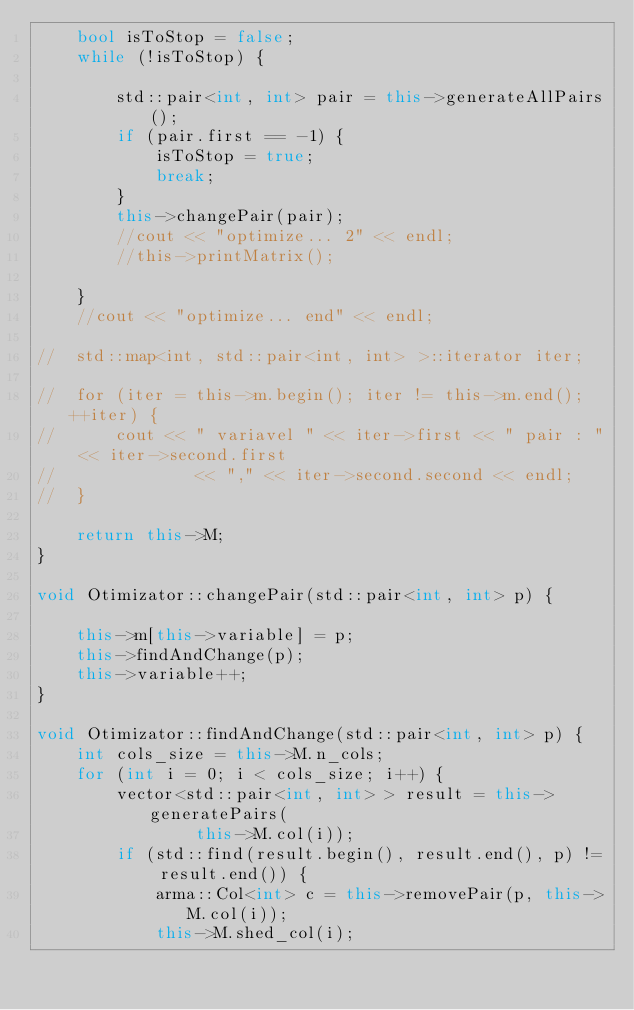Convert code to text. <code><loc_0><loc_0><loc_500><loc_500><_C++_>	bool isToStop = false;
	while (!isToStop) {

		std::pair<int, int> pair = this->generateAllPairs();
		if (pair.first == -1) {
			isToStop = true;
			break;
		}
		this->changePair(pair);
		//cout << "optimize... 2" << endl;
		//this->printMatrix();

	}
	//cout << "optimize... end" << endl;

//	std::map<int, std::pair<int, int> >::iterator iter;

//	for (iter = this->m.begin(); iter != this->m.end(); ++iter) {
//		cout << " variavel " << iter->first << " pair : " << iter->second.first
//				<< "," << iter->second.second << endl;
//	}

	return this->M;
}

void Otimizator::changePair(std::pair<int, int> p) {

	this->m[this->variable] = p;
	this->findAndChange(p);
	this->variable++;
}

void Otimizator::findAndChange(std::pair<int, int> p) {
	int cols_size = this->M.n_cols;
	for (int i = 0; i < cols_size; i++) {
		vector<std::pair<int, int> > result = this->generatePairs(
				this->M.col(i));
		if (std::find(result.begin(), result.end(), p) != result.end()) {
			arma::Col<int> c = this->removePair(p, this->M.col(i));
			this->M.shed_col(i);</code> 